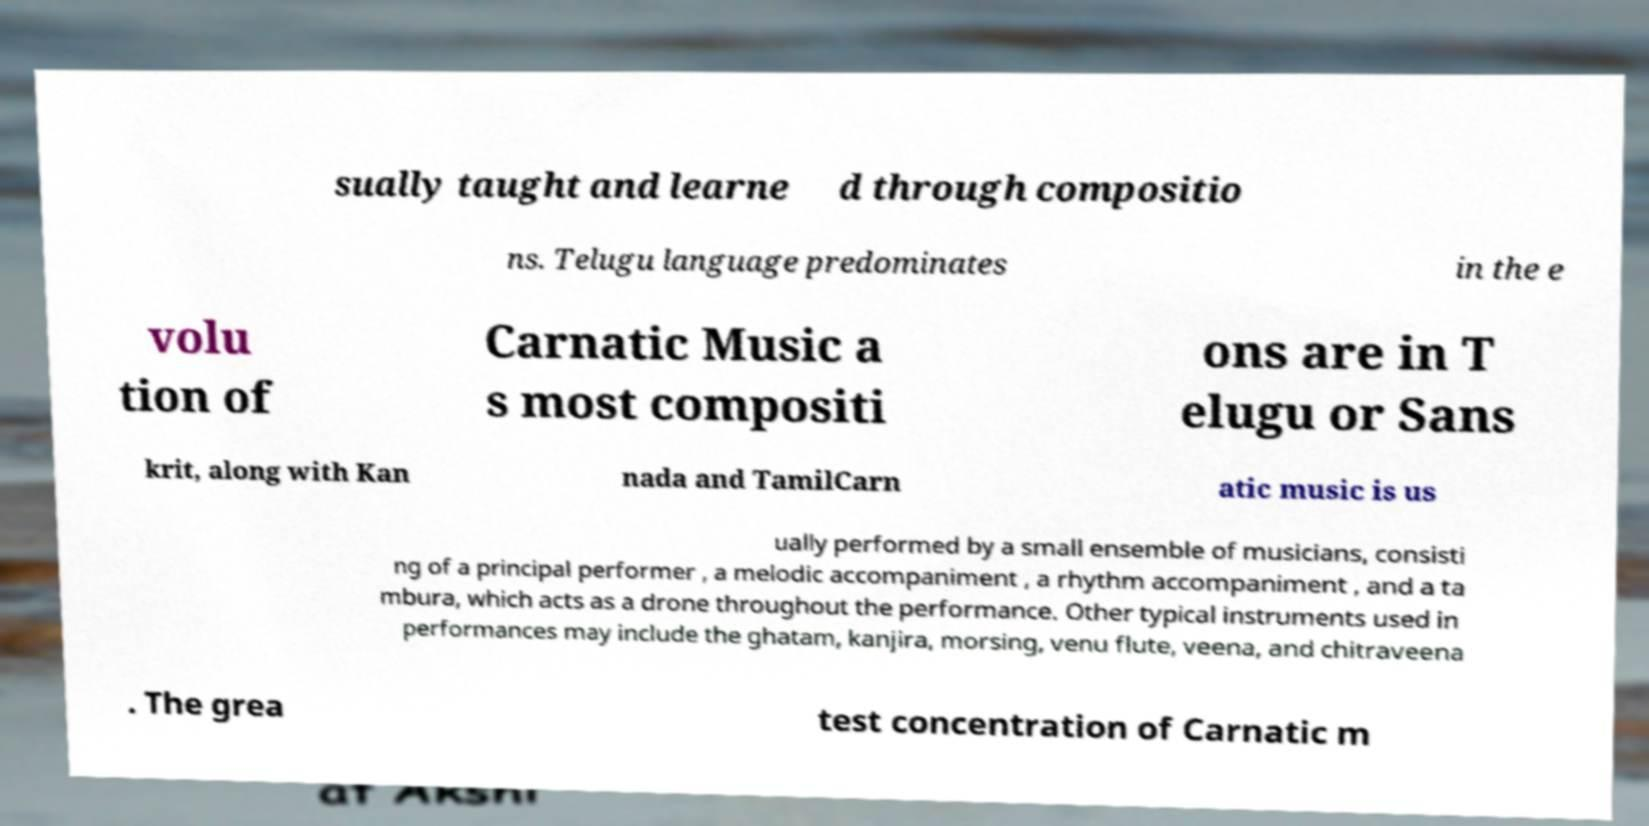There's text embedded in this image that I need extracted. Can you transcribe it verbatim? sually taught and learne d through compositio ns. Telugu language predominates in the e volu tion of Carnatic Music a s most compositi ons are in T elugu or Sans krit, along with Kan nada and TamilCarn atic music is us ually performed by a small ensemble of musicians, consisti ng of a principal performer , a melodic accompaniment , a rhythm accompaniment , and a ta mbura, which acts as a drone throughout the performance. Other typical instruments used in performances may include the ghatam, kanjira, morsing, venu flute, veena, and chitraveena . The grea test concentration of Carnatic m 